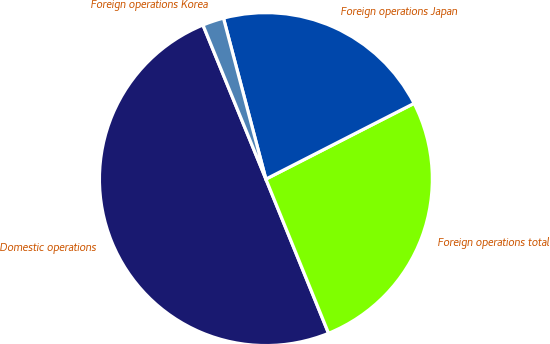<chart> <loc_0><loc_0><loc_500><loc_500><pie_chart><fcel>Domestic operations<fcel>Foreign operations total<fcel>Foreign operations Japan<fcel>Foreign operations Korea<nl><fcel>49.97%<fcel>26.37%<fcel>21.58%<fcel>2.07%<nl></chart> 